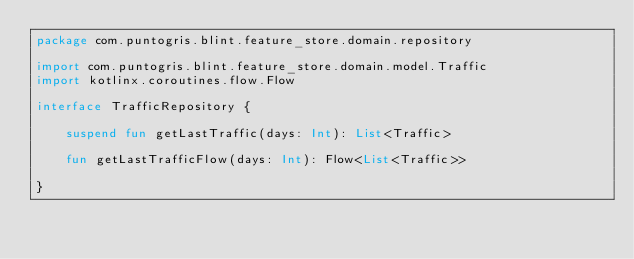Convert code to text. <code><loc_0><loc_0><loc_500><loc_500><_Kotlin_>package com.puntogris.blint.feature_store.domain.repository

import com.puntogris.blint.feature_store.domain.model.Traffic
import kotlinx.coroutines.flow.Flow

interface TrafficRepository {

    suspend fun getLastTraffic(days: Int): List<Traffic>

    fun getLastTrafficFlow(days: Int): Flow<List<Traffic>>

}</code> 